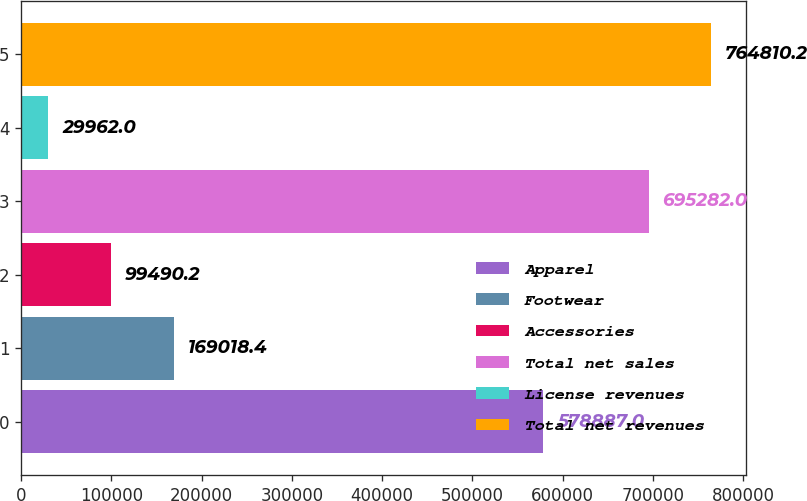<chart> <loc_0><loc_0><loc_500><loc_500><bar_chart><fcel>Apparel<fcel>Footwear<fcel>Accessories<fcel>Total net sales<fcel>License revenues<fcel>Total net revenues<nl><fcel>578887<fcel>169018<fcel>99490.2<fcel>695282<fcel>29962<fcel>764810<nl></chart> 